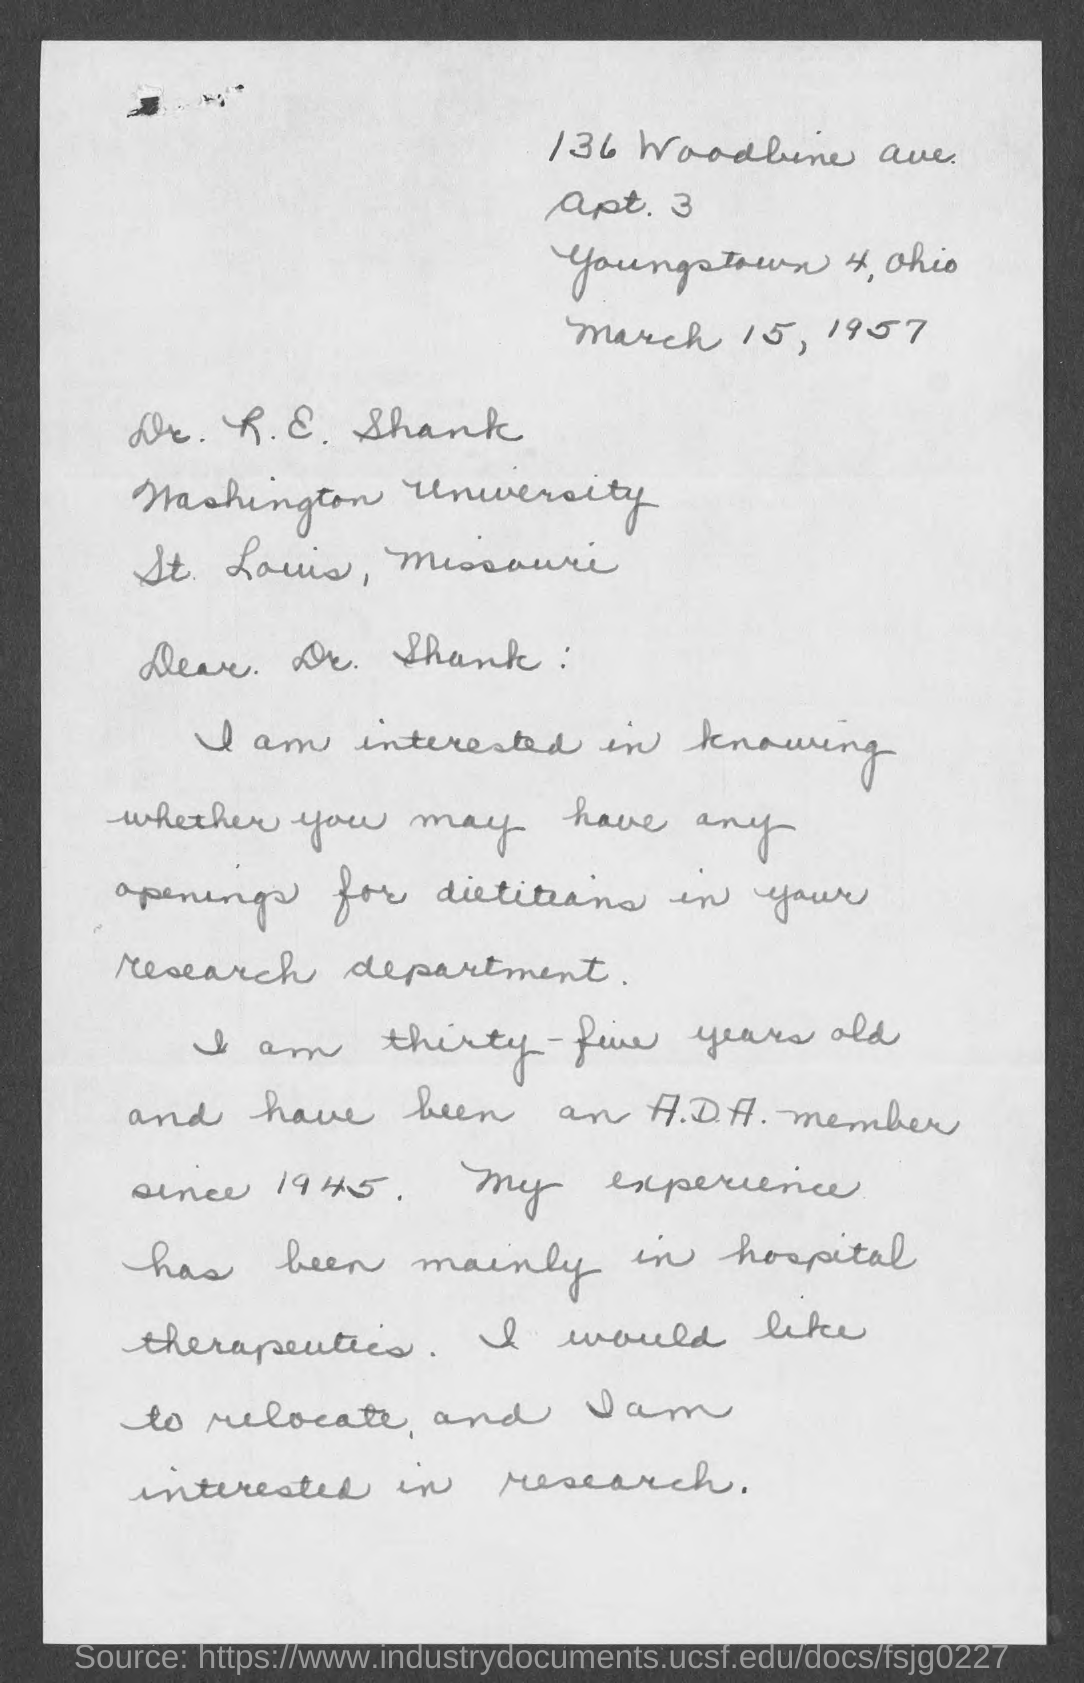Draw attention to some important aspects in this diagram. The date mentioned in the given letter is March 15, 1957. 